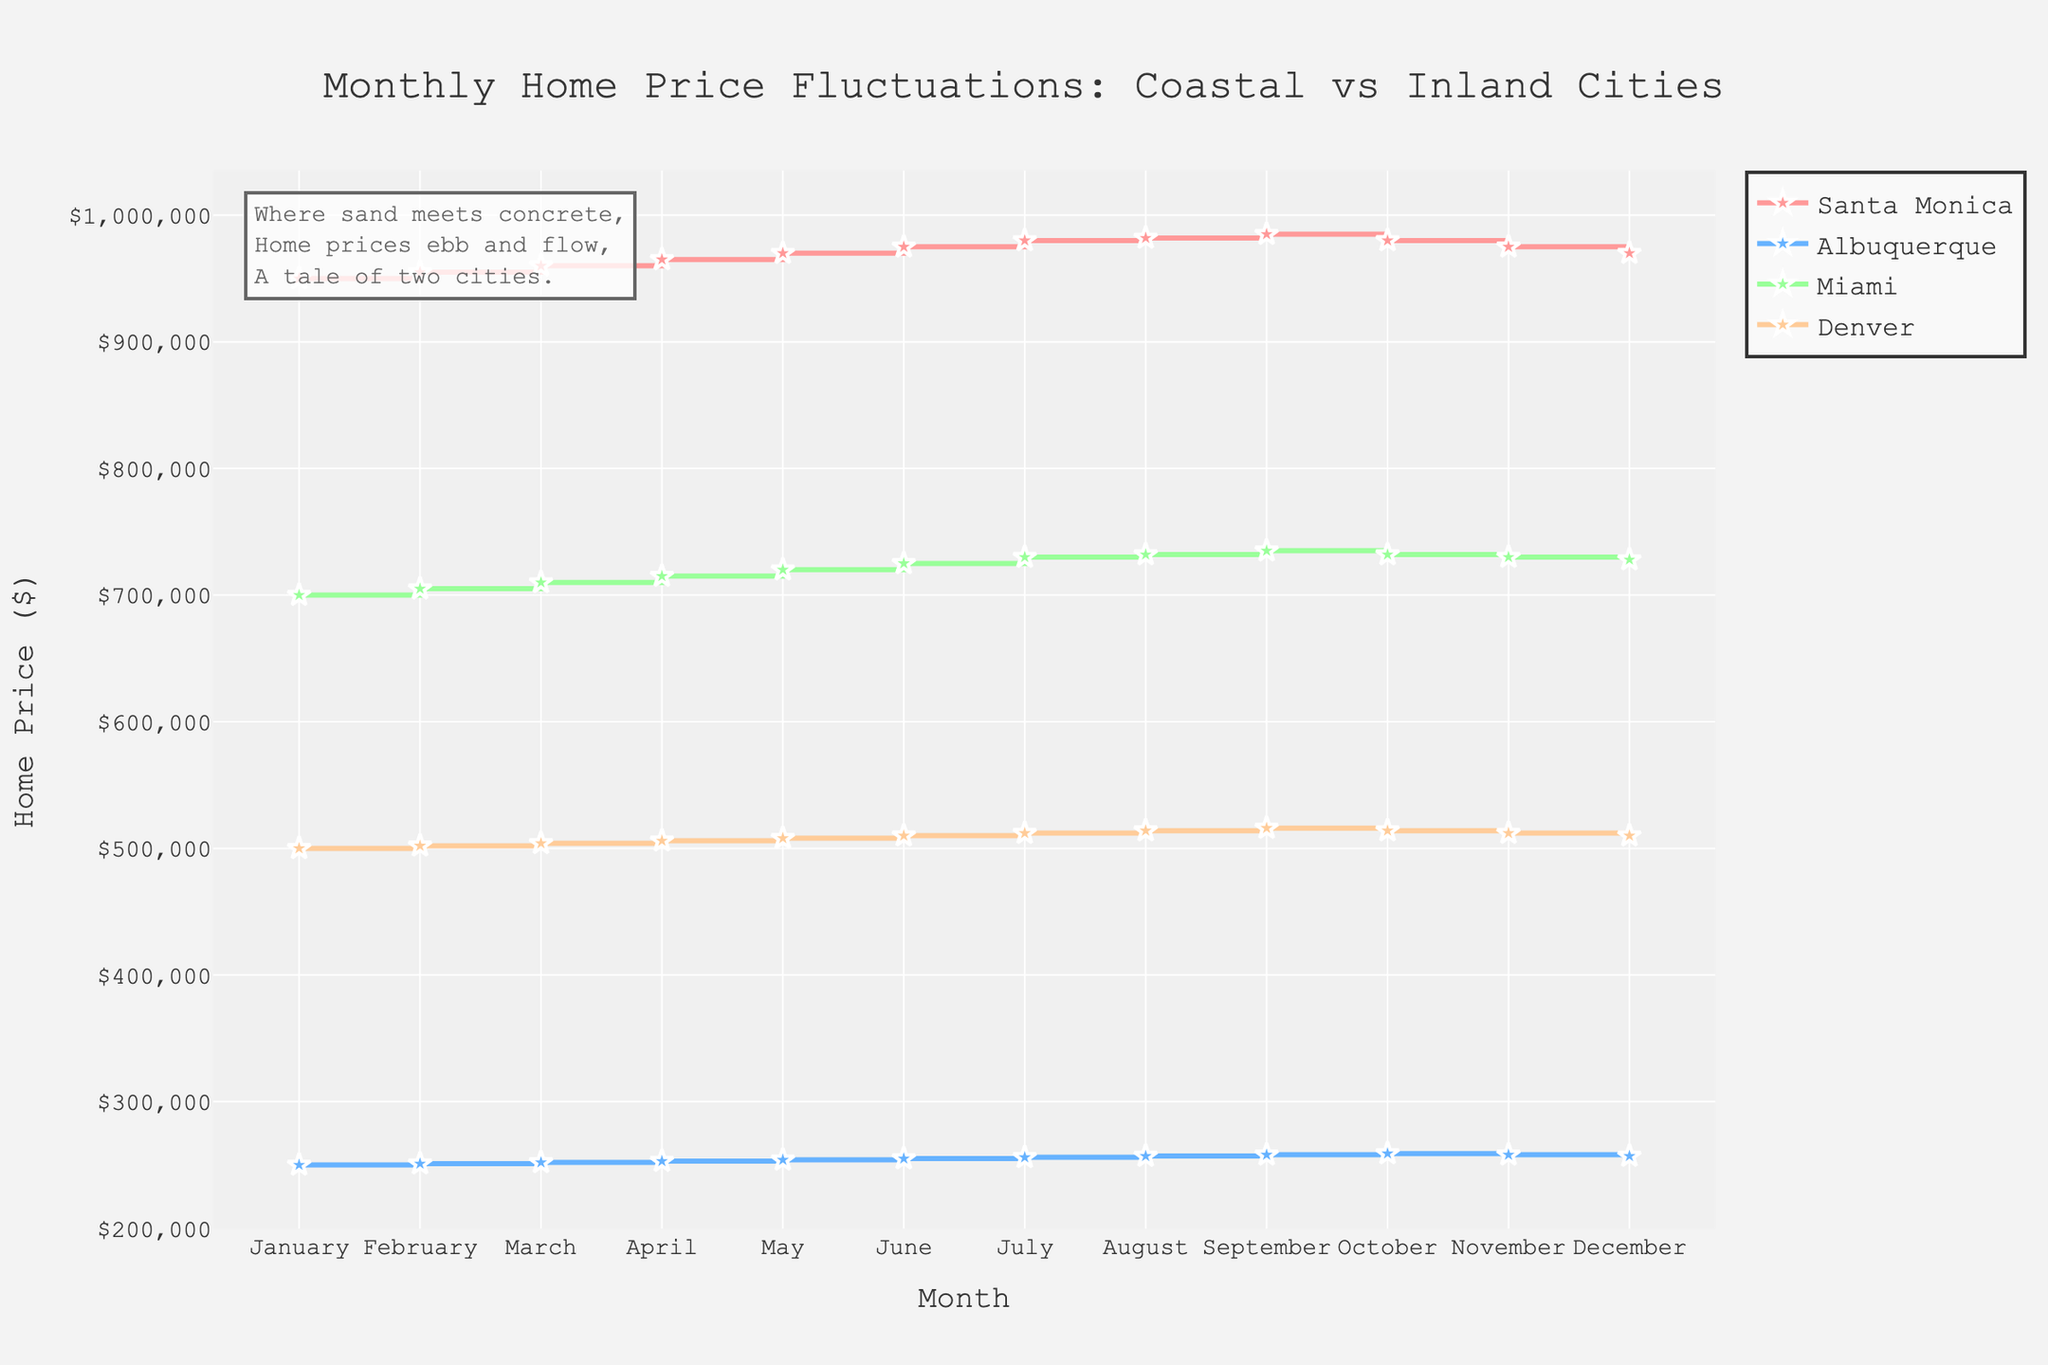Which city has the highest home price in January? To determine the highest home price in January, check the y-values (home prices) for all cities at the x-value corresponding to January. Santa Monica has a home price of $950,000, Albuquerque $250,000, Miami $700,000, and Denver $500,000. Santa Monica has the highest price.
Answer: Santa Monica How do the home prices in Santa Monica and Albuquerque compare in December? Compare the y-values for Santa Monica and Albuquerque at the x-value corresponding to December. Santa Monica has a home price of $970,000, while Albuquerque has $257,000, making Santa Monica's price significantly higher.
Answer: Santa Monica's price is higher Which city shows a decrease in home price from October to December? Check the y-values for each city from October to December. Each city except Santa Monica shows this decrease. Santa Monica's values are October $980,000, November $975,000, December $970,000. Albuquerque's values are October $259,000, November $258,000, December $257,000. Similarly, Miami and Denver also decrease, with their October to December values being Miami: $732,000 to $728,000 and Denver: $514,000 to $510,000.
Answer: All cities show a decrease What is the average home price in Miami over the 12 months? Sum the monthly home prices in Miami and divide by 12. Add the prices: $700,000 + $705,000 + $710,000 + $715,000 + $720,000 + $725,000 + $730,000 + $732,000 + $735,000 + $732,000 + $730,000 + $728,000 = $8,662,000. The average is $8,662,000 / 12 = $721,833.33
Answer: $721,833.33 Are the fluctuations in home prices larger in coastal or inland cities? Compare the month-to-month changes in home prices for coastal (Santa Monica and Miami) and inland (Albuquerque and Denver) cities. Coastal cities like Santa Monica vary from $950,000 to $985,000, and Miami from $700,000 to $735,000. Inland cities like Albuquerque have a smaller range from $250,000 to $259,000, and Denver from $500,000 to $516,000. Coastal cities show larger fluctuations.
Answer: Coastal cities In terms of seasonal fluctuation, how does Denver compare to Miami? Analyze the variation of home prices over the year. Denver’s home prices start at $500,000 in January and peak at $516,000 in September before decreasing to $510,000 in December. Miami starts at $700,000 in January, peaks at $735,000 in September, and then decreases to $728,000 in December. Both cities have cyclical patterns, but Miami has a higher overall range and more pronounced seasonal fluctuation.
Answer: Miami has more fluctuation What is the difference between the highest and lowest home prices in Santa Monica? Identify the highest and lowest points on the Santa Monica line. The highest home price is $985,000 in September, and the lowest is $950,000 in January. The difference is $985,000 - $950,000 = $35,000.
Answer: $35,000 At which months do Miami and Santa Monica have the same home price trend (increase or decrease)? Observe the monthly changes for both Miami and Santa Monica to find the months with the same direction. Both increase from January to September and decrease from October to December. Therefore, they have the same trend in every month.
Answer: Every month 